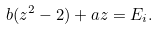Convert formula to latex. <formula><loc_0><loc_0><loc_500><loc_500>b ( z ^ { 2 } - 2 ) + a z = E _ { i } .</formula> 